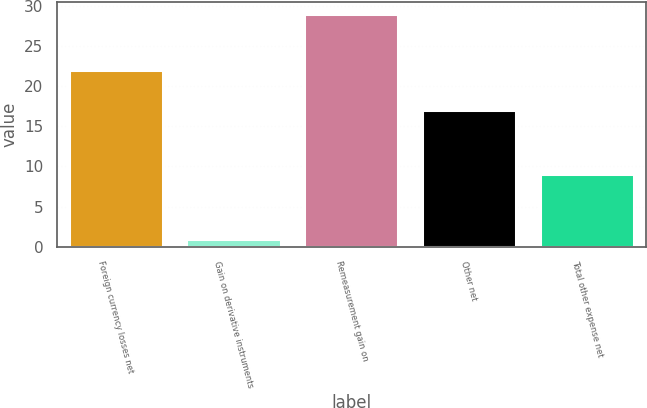<chart> <loc_0><loc_0><loc_500><loc_500><bar_chart><fcel>Foreign currency losses net<fcel>Gain on derivative instruments<fcel>Remeasurement gain on<fcel>Other net<fcel>Total other expense net<nl><fcel>22<fcel>1<fcel>29<fcel>17<fcel>9<nl></chart> 